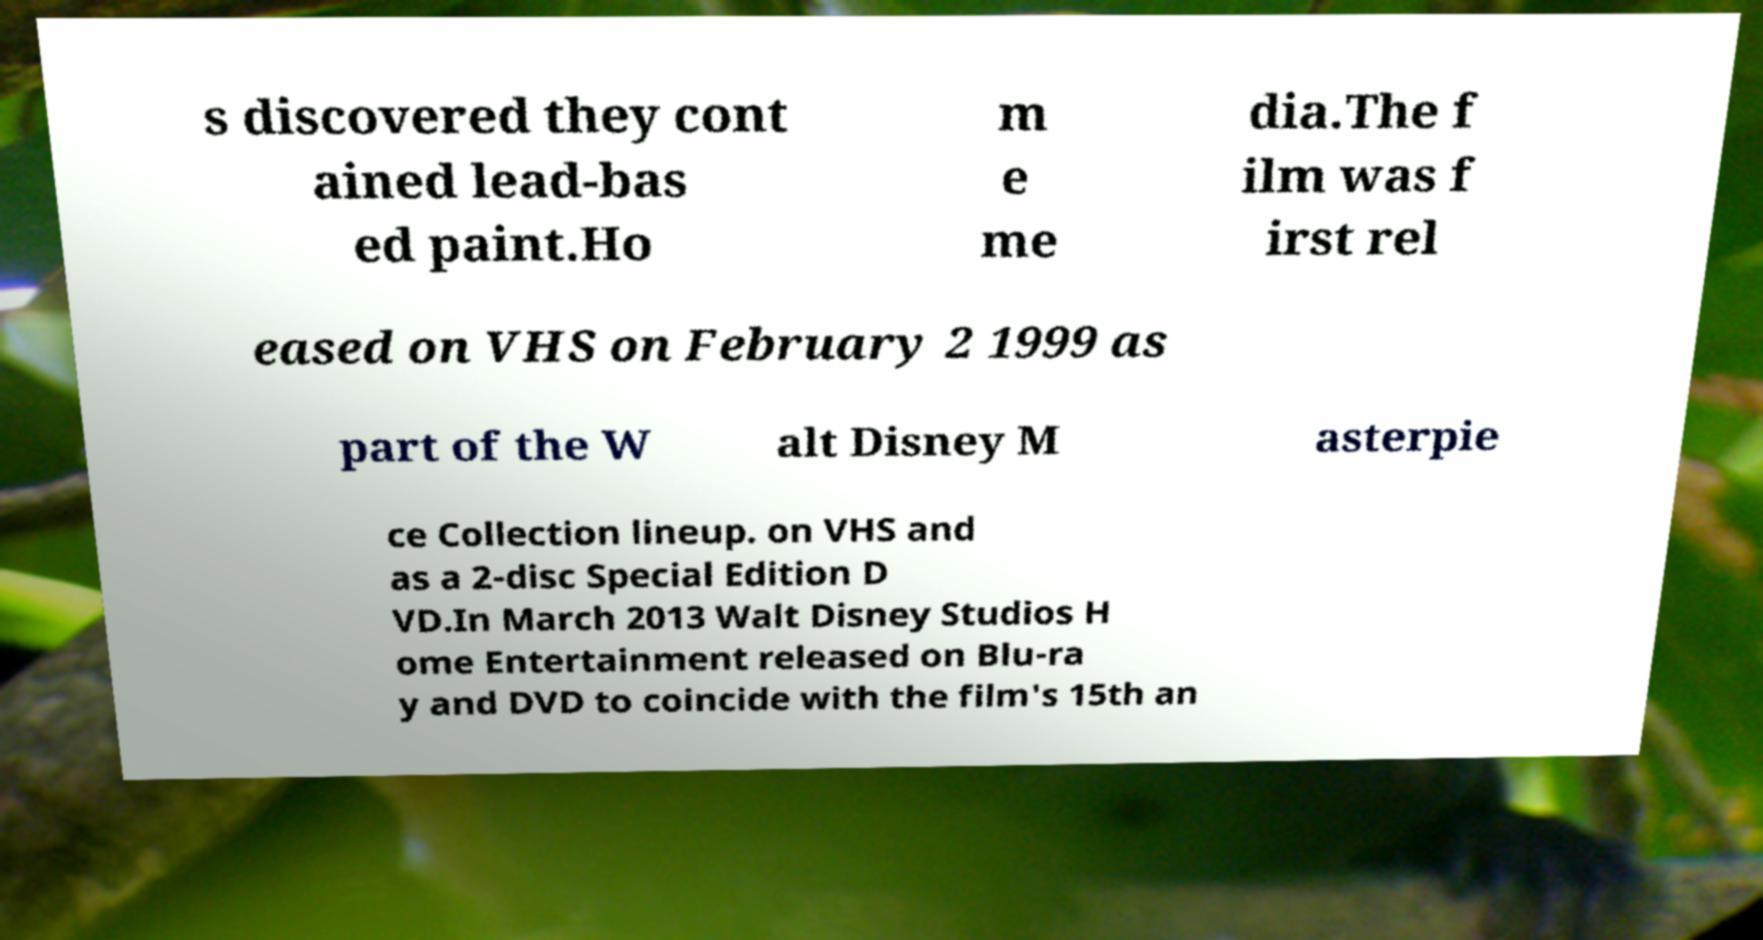I need the written content from this picture converted into text. Can you do that? s discovered they cont ained lead-bas ed paint.Ho m e me dia.The f ilm was f irst rel eased on VHS on February 2 1999 as part of the W alt Disney M asterpie ce Collection lineup. on VHS and as a 2-disc Special Edition D VD.In March 2013 Walt Disney Studios H ome Entertainment released on Blu-ra y and DVD to coincide with the film's 15th an 